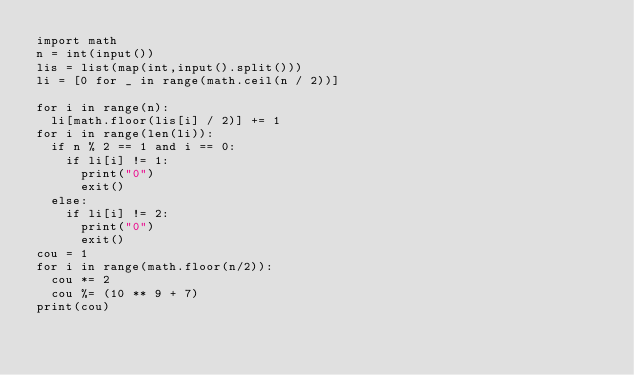<code> <loc_0><loc_0><loc_500><loc_500><_Python_>import math
n = int(input())
lis = list(map(int,input().split()))
li = [0 for _ in range(math.ceil(n / 2))]

for i in range(n):
  li[math.floor(lis[i] / 2)] += 1
for i in range(len(li)):
  if n % 2 == 1 and i == 0:
    if li[i] != 1:
      print("0")
      exit()
  else:
    if li[i] != 2:
      print("0")
      exit()
cou = 1
for i in range(math.floor(n/2)):
  cou *= 2
  cou %= (10 ** 9 + 7)
print(cou)</code> 